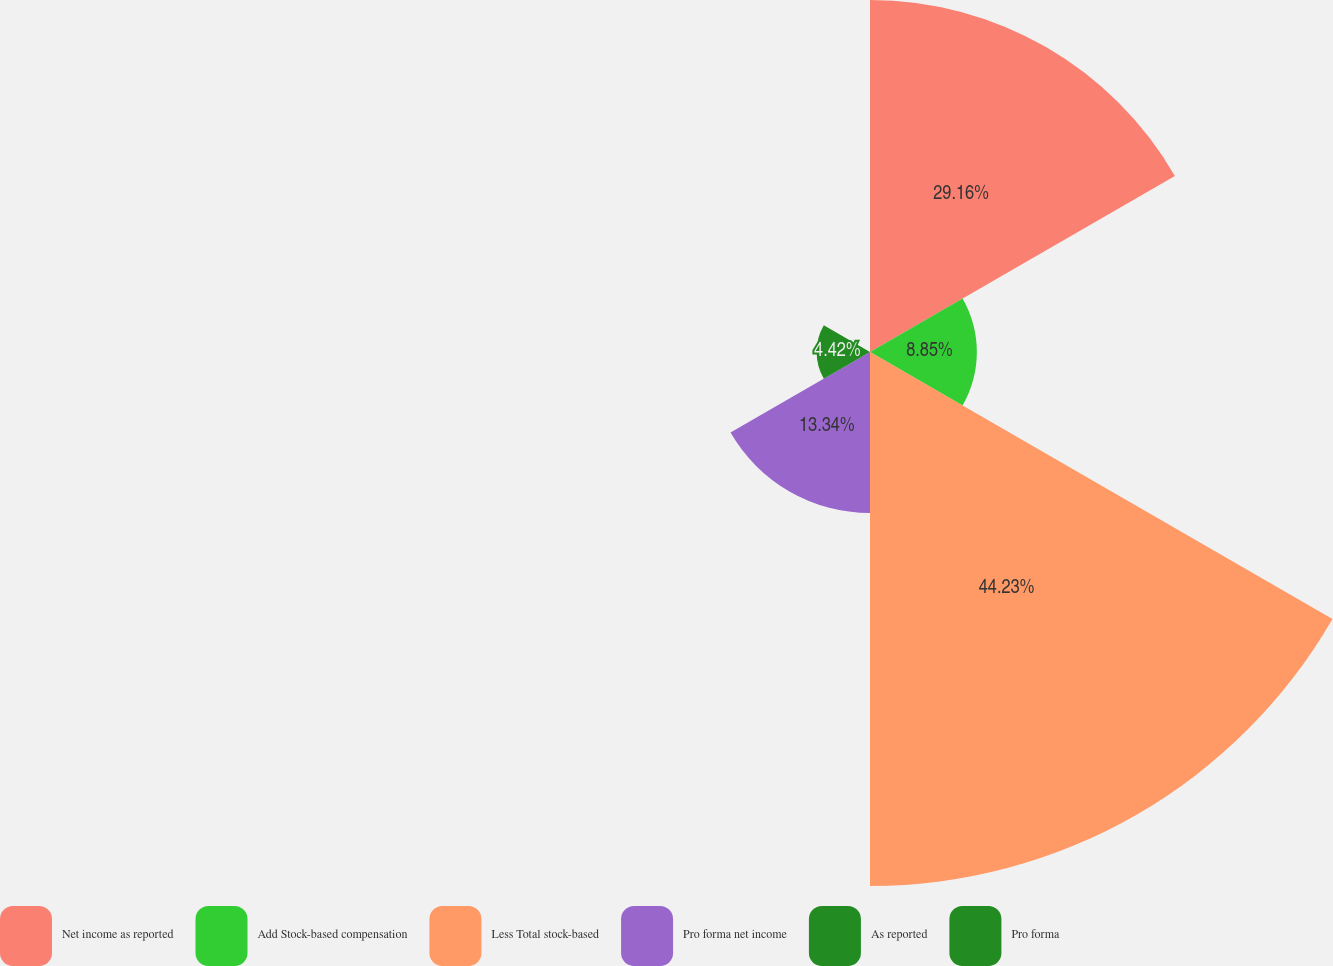Convert chart. <chart><loc_0><loc_0><loc_500><loc_500><pie_chart><fcel>Net income as reported<fcel>Add Stock-based compensation<fcel>Less Total stock-based<fcel>Pro forma net income<fcel>As reported<fcel>Pro forma<nl><fcel>29.16%<fcel>8.85%<fcel>44.23%<fcel>13.34%<fcel>4.42%<fcel>0.0%<nl></chart> 